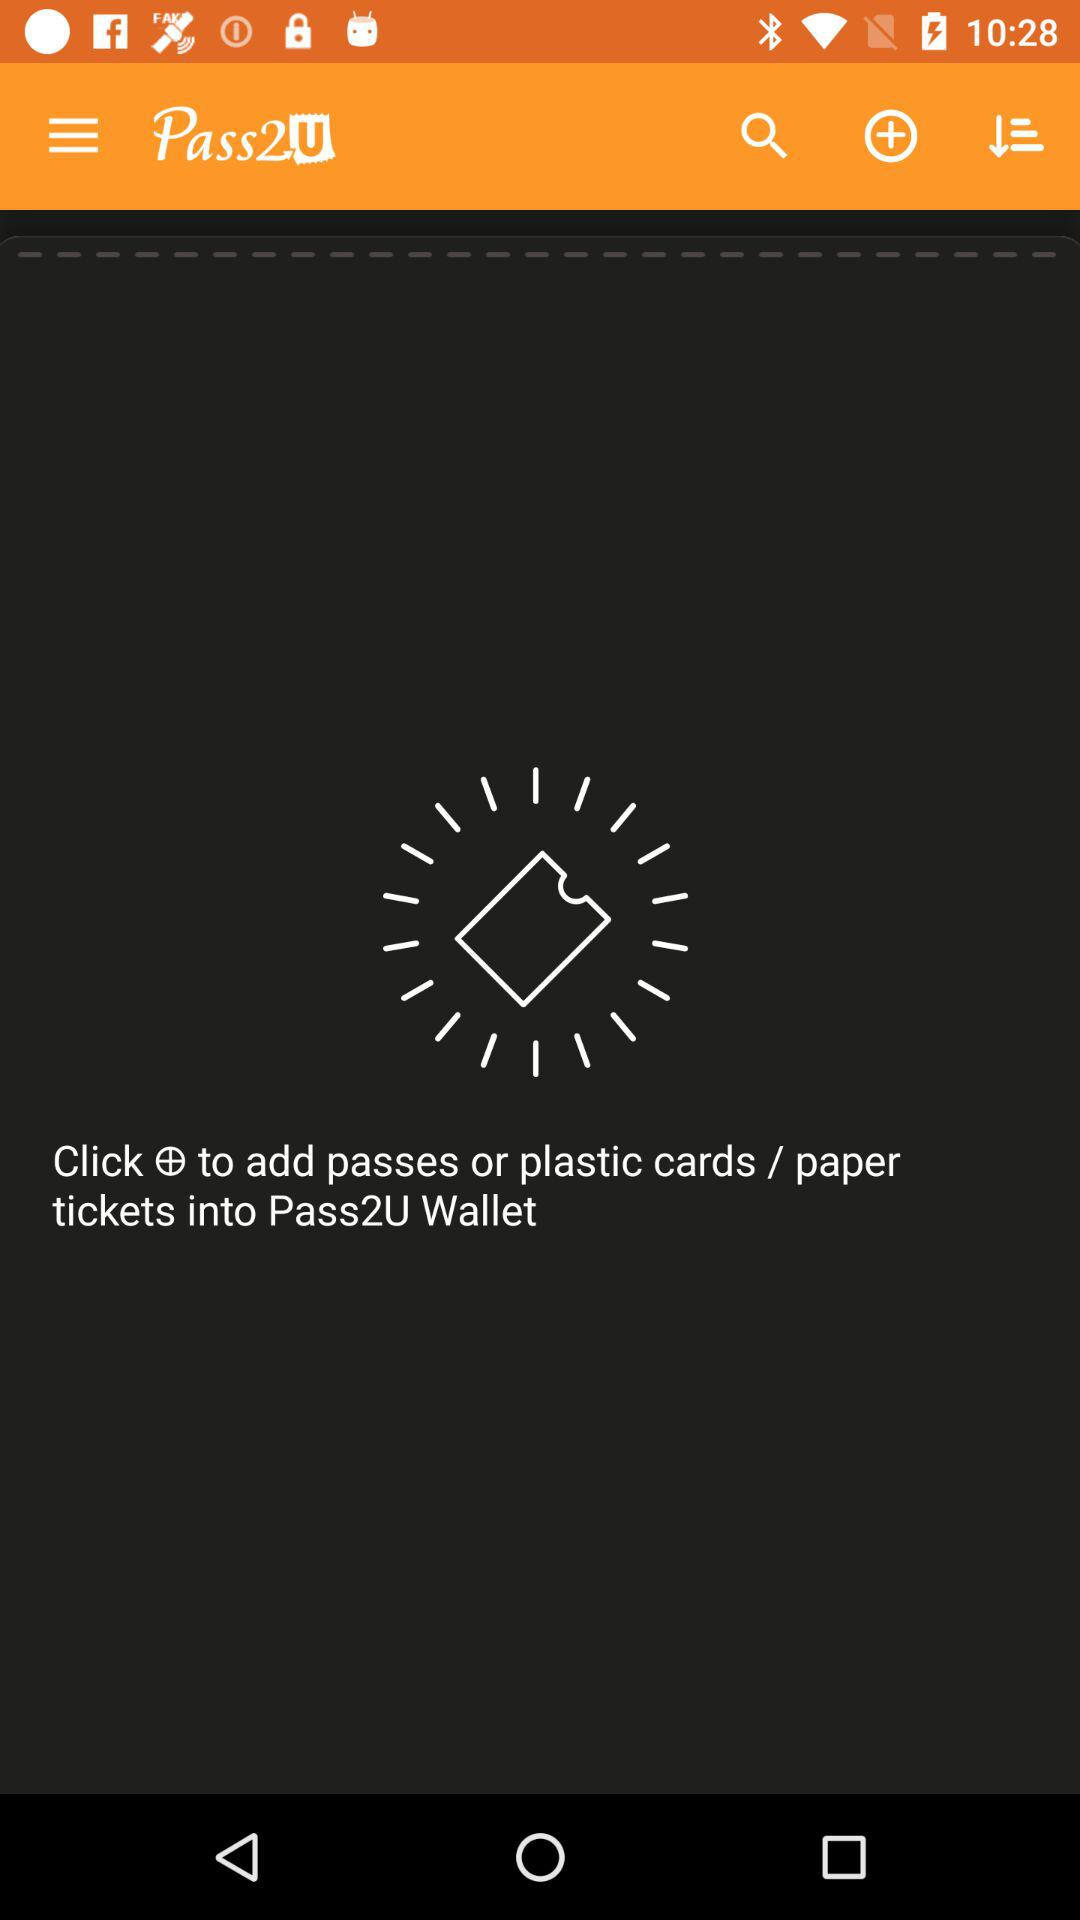What is the application name? The application name is "Pass2U Wallet". 